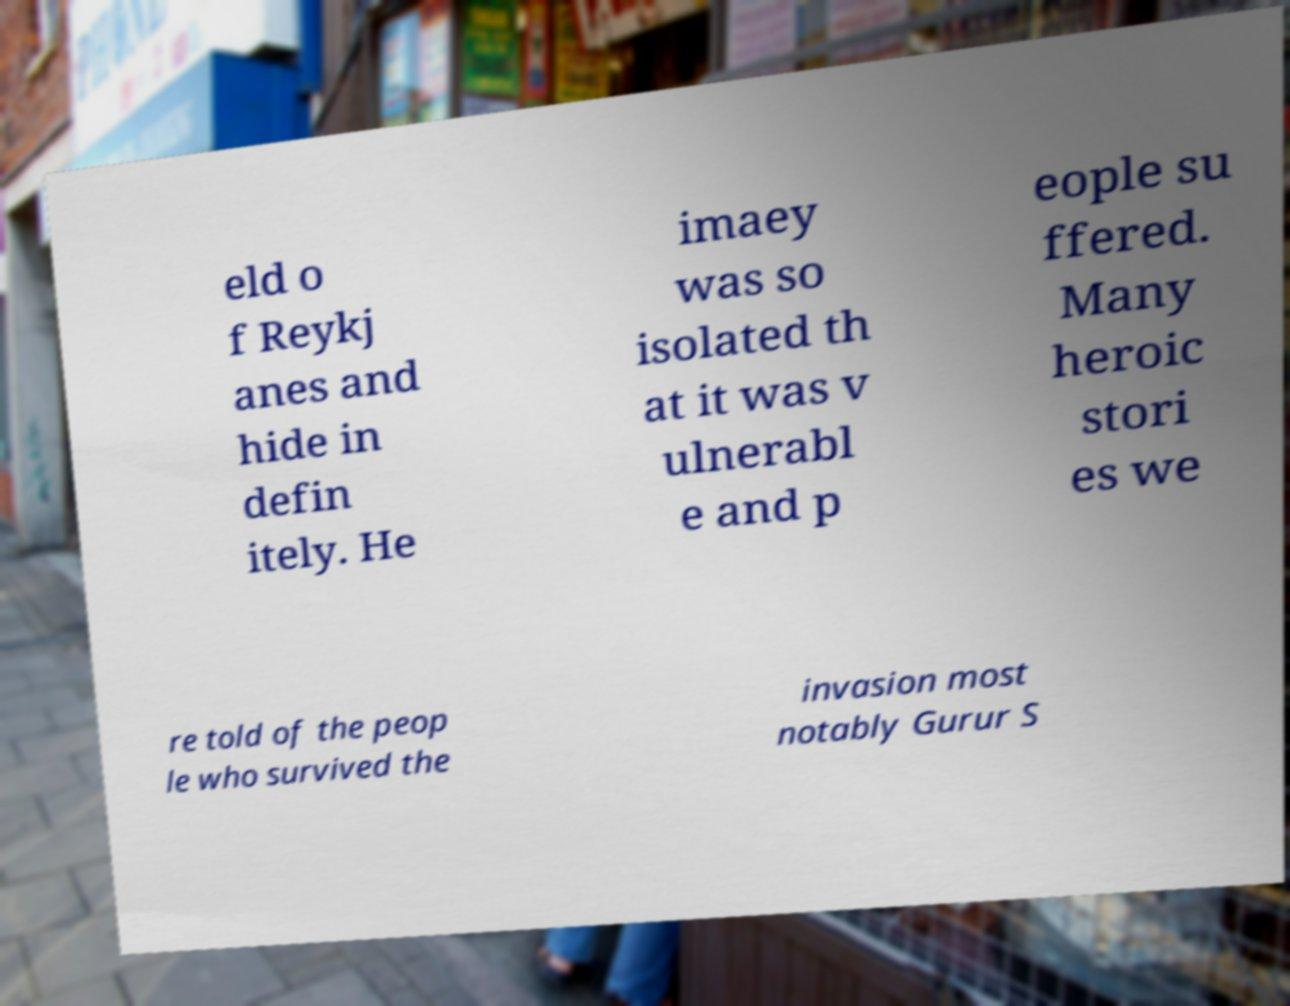Can you accurately transcribe the text from the provided image for me? eld o f Reykj anes and hide in defin itely. He imaey was so isolated th at it was v ulnerabl e and p eople su ffered. Many heroic stori es we re told of the peop le who survived the invasion most notably Gurur S 